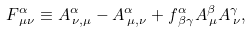Convert formula to latex. <formula><loc_0><loc_0><loc_500><loc_500>F _ { \, \mu \nu } ^ { \alpha } \equiv A _ { \, \nu , \mu } ^ { \alpha } - A _ { \, \mu , \nu } ^ { \alpha } + f _ { \, \beta \gamma } ^ { \alpha } A _ { \, \mu } ^ { \beta } A _ { \, \nu } ^ { \gamma } ,</formula> 